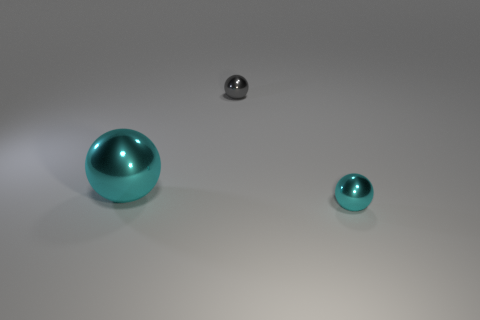Are there an equal number of cyan objects right of the gray shiny sphere and balls that are in front of the tiny cyan shiny thing?
Offer a very short reply. No. What number of large metallic spheres are on the left side of the large shiny ball?
Provide a succinct answer. 0. How many things are either cyan objects or small cyan shiny spheres?
Make the answer very short. 2. What number of green matte cylinders are the same size as the gray shiny object?
Offer a terse response. 0. There is a small object in front of the small sphere to the left of the small cyan thing; what is its shape?
Provide a short and direct response. Sphere. Are there fewer small cyan metallic objects than shiny objects?
Ensure brevity in your answer.  Yes. There is a tiny metal object that is behind the tiny cyan metallic object; what color is it?
Provide a succinct answer. Gray. There is a sphere that is in front of the gray sphere and on the right side of the big shiny thing; what material is it?
Make the answer very short. Metal. There is a gray thing that is the same material as the big cyan ball; what is its shape?
Your answer should be very brief. Sphere. What number of tiny objects are behind the cyan sphere that is in front of the large cyan ball?
Your answer should be very brief. 1. 